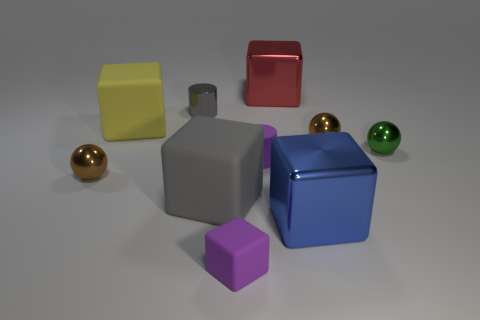Are the green thing and the large red object made of the same material?
Your answer should be very brief. Yes. How many other objects are the same color as the tiny rubber cube?
Your answer should be compact. 1. What is the shape of the big matte object that is in front of the large yellow rubber cube?
Offer a very short reply. Cube. What number of things are either rubber cubes or big red matte cubes?
Make the answer very short. 3. There is a red metal block; is its size the same as the brown object right of the large red cube?
Your answer should be very brief. No. How many other things are there of the same material as the small gray cylinder?
Your answer should be compact. 5. What number of things are either gray rubber cubes in front of the small green ball or tiny things behind the blue shiny block?
Offer a very short reply. 6. There is a purple object that is the same shape as the large gray object; what is its material?
Your answer should be very brief. Rubber. Are any gray matte spheres visible?
Provide a short and direct response. No. There is a cube that is behind the green object and to the left of the red block; how big is it?
Make the answer very short. Large. 